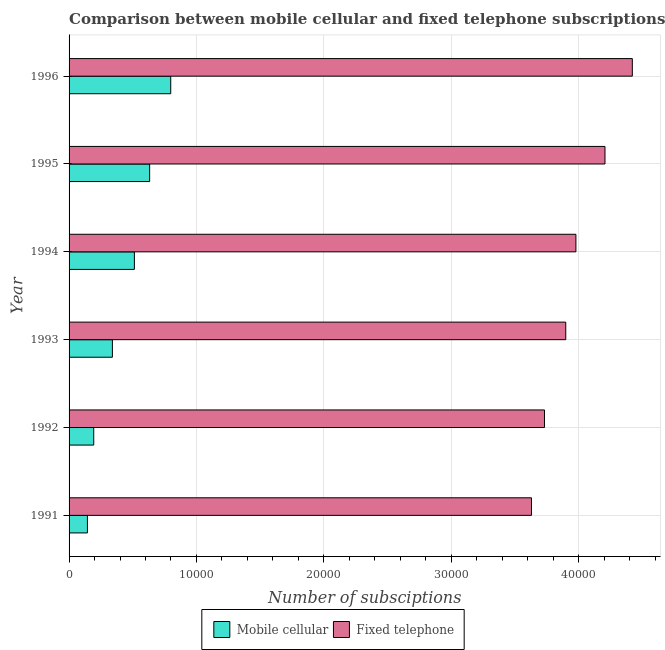How many groups of bars are there?
Your response must be concise. 6. How many bars are there on the 6th tick from the top?
Give a very brief answer. 2. What is the label of the 2nd group of bars from the top?
Keep it short and to the point. 1995. In how many cases, is the number of bars for a given year not equal to the number of legend labels?
Your response must be concise. 0. What is the number of mobile cellular subscriptions in 1993?
Make the answer very short. 3400. Across all years, what is the maximum number of mobile cellular subscriptions?
Offer a terse response. 7980. Across all years, what is the minimum number of mobile cellular subscriptions?
Offer a terse response. 1440. In which year was the number of mobile cellular subscriptions maximum?
Ensure brevity in your answer.  1996. In which year was the number of mobile cellular subscriptions minimum?
Make the answer very short. 1991. What is the total number of fixed telephone subscriptions in the graph?
Your response must be concise. 2.39e+05. What is the difference between the number of fixed telephone subscriptions in 1992 and that in 1995?
Your answer should be compact. -4749. What is the difference between the number of mobile cellular subscriptions in 1995 and the number of fixed telephone subscriptions in 1994?
Offer a very short reply. -3.35e+04. What is the average number of fixed telephone subscriptions per year?
Provide a short and direct response. 3.98e+04. In the year 1994, what is the difference between the number of mobile cellular subscriptions and number of fixed telephone subscriptions?
Give a very brief answer. -3.47e+04. What is the ratio of the number of mobile cellular subscriptions in 1995 to that in 1996?
Your answer should be compact. 0.79. Is the number of fixed telephone subscriptions in 1991 less than that in 1992?
Your response must be concise. Yes. What is the difference between the highest and the second highest number of fixed telephone subscriptions?
Provide a short and direct response. 2147. What is the difference between the highest and the lowest number of mobile cellular subscriptions?
Ensure brevity in your answer.  6540. In how many years, is the number of fixed telephone subscriptions greater than the average number of fixed telephone subscriptions taken over all years?
Make the answer very short. 3. Is the sum of the number of fixed telephone subscriptions in 1991 and 1994 greater than the maximum number of mobile cellular subscriptions across all years?
Keep it short and to the point. Yes. What does the 1st bar from the top in 1994 represents?
Your answer should be very brief. Fixed telephone. What does the 2nd bar from the bottom in 1991 represents?
Ensure brevity in your answer.  Fixed telephone. How many bars are there?
Your answer should be very brief. 12. How many years are there in the graph?
Ensure brevity in your answer.  6. Are the values on the major ticks of X-axis written in scientific E-notation?
Your response must be concise. No. Where does the legend appear in the graph?
Offer a very short reply. Bottom center. How are the legend labels stacked?
Your response must be concise. Horizontal. What is the title of the graph?
Ensure brevity in your answer.  Comparison between mobile cellular and fixed telephone subscriptions in Bermuda. Does "Canada" appear as one of the legend labels in the graph?
Keep it short and to the point. No. What is the label or title of the X-axis?
Give a very brief answer. Number of subsciptions. What is the Number of subsciptions in Mobile cellular in 1991?
Your response must be concise. 1440. What is the Number of subsciptions of Fixed telephone in 1991?
Provide a succinct answer. 3.63e+04. What is the Number of subsciptions of Mobile cellular in 1992?
Your answer should be compact. 1936. What is the Number of subsciptions of Fixed telephone in 1992?
Provide a short and direct response. 3.73e+04. What is the Number of subsciptions in Mobile cellular in 1993?
Your answer should be very brief. 3400. What is the Number of subsciptions of Fixed telephone in 1993?
Make the answer very short. 3.90e+04. What is the Number of subsciptions of Mobile cellular in 1994?
Ensure brevity in your answer.  5127. What is the Number of subsciptions in Fixed telephone in 1994?
Offer a terse response. 3.98e+04. What is the Number of subsciptions in Mobile cellular in 1995?
Make the answer very short. 6324. What is the Number of subsciptions in Fixed telephone in 1995?
Your answer should be very brief. 4.21e+04. What is the Number of subsciptions in Mobile cellular in 1996?
Provide a succinct answer. 7980. What is the Number of subsciptions in Fixed telephone in 1996?
Your response must be concise. 4.42e+04. Across all years, what is the maximum Number of subsciptions in Mobile cellular?
Ensure brevity in your answer.  7980. Across all years, what is the maximum Number of subsciptions in Fixed telephone?
Offer a very short reply. 4.42e+04. Across all years, what is the minimum Number of subsciptions in Mobile cellular?
Provide a succinct answer. 1440. Across all years, what is the minimum Number of subsciptions of Fixed telephone?
Provide a succinct answer. 3.63e+04. What is the total Number of subsciptions of Mobile cellular in the graph?
Give a very brief answer. 2.62e+04. What is the total Number of subsciptions in Fixed telephone in the graph?
Your response must be concise. 2.39e+05. What is the difference between the Number of subsciptions of Mobile cellular in 1991 and that in 1992?
Keep it short and to the point. -496. What is the difference between the Number of subsciptions of Fixed telephone in 1991 and that in 1992?
Provide a succinct answer. -1021. What is the difference between the Number of subsciptions in Mobile cellular in 1991 and that in 1993?
Keep it short and to the point. -1960. What is the difference between the Number of subsciptions in Fixed telephone in 1991 and that in 1993?
Keep it short and to the point. -2691. What is the difference between the Number of subsciptions in Mobile cellular in 1991 and that in 1994?
Your answer should be compact. -3687. What is the difference between the Number of subsciptions of Fixed telephone in 1991 and that in 1994?
Make the answer very short. -3488. What is the difference between the Number of subsciptions in Mobile cellular in 1991 and that in 1995?
Your answer should be very brief. -4884. What is the difference between the Number of subsciptions in Fixed telephone in 1991 and that in 1995?
Give a very brief answer. -5770. What is the difference between the Number of subsciptions in Mobile cellular in 1991 and that in 1996?
Make the answer very short. -6540. What is the difference between the Number of subsciptions of Fixed telephone in 1991 and that in 1996?
Your answer should be very brief. -7917. What is the difference between the Number of subsciptions of Mobile cellular in 1992 and that in 1993?
Your response must be concise. -1464. What is the difference between the Number of subsciptions in Fixed telephone in 1992 and that in 1993?
Give a very brief answer. -1670. What is the difference between the Number of subsciptions of Mobile cellular in 1992 and that in 1994?
Provide a short and direct response. -3191. What is the difference between the Number of subsciptions in Fixed telephone in 1992 and that in 1994?
Ensure brevity in your answer.  -2467. What is the difference between the Number of subsciptions of Mobile cellular in 1992 and that in 1995?
Make the answer very short. -4388. What is the difference between the Number of subsciptions in Fixed telephone in 1992 and that in 1995?
Your answer should be very brief. -4749. What is the difference between the Number of subsciptions of Mobile cellular in 1992 and that in 1996?
Your response must be concise. -6044. What is the difference between the Number of subsciptions of Fixed telephone in 1992 and that in 1996?
Your answer should be very brief. -6896. What is the difference between the Number of subsciptions of Mobile cellular in 1993 and that in 1994?
Give a very brief answer. -1727. What is the difference between the Number of subsciptions in Fixed telephone in 1993 and that in 1994?
Keep it short and to the point. -797. What is the difference between the Number of subsciptions in Mobile cellular in 1993 and that in 1995?
Your answer should be compact. -2924. What is the difference between the Number of subsciptions in Fixed telephone in 1993 and that in 1995?
Keep it short and to the point. -3079. What is the difference between the Number of subsciptions in Mobile cellular in 1993 and that in 1996?
Provide a succinct answer. -4580. What is the difference between the Number of subsciptions in Fixed telephone in 1993 and that in 1996?
Offer a terse response. -5226. What is the difference between the Number of subsciptions in Mobile cellular in 1994 and that in 1995?
Give a very brief answer. -1197. What is the difference between the Number of subsciptions in Fixed telephone in 1994 and that in 1995?
Ensure brevity in your answer.  -2282. What is the difference between the Number of subsciptions in Mobile cellular in 1994 and that in 1996?
Ensure brevity in your answer.  -2853. What is the difference between the Number of subsciptions of Fixed telephone in 1994 and that in 1996?
Keep it short and to the point. -4429. What is the difference between the Number of subsciptions of Mobile cellular in 1995 and that in 1996?
Ensure brevity in your answer.  -1656. What is the difference between the Number of subsciptions of Fixed telephone in 1995 and that in 1996?
Your response must be concise. -2147. What is the difference between the Number of subsciptions in Mobile cellular in 1991 and the Number of subsciptions in Fixed telephone in 1992?
Your answer should be very brief. -3.59e+04. What is the difference between the Number of subsciptions of Mobile cellular in 1991 and the Number of subsciptions of Fixed telephone in 1993?
Provide a short and direct response. -3.75e+04. What is the difference between the Number of subsciptions in Mobile cellular in 1991 and the Number of subsciptions in Fixed telephone in 1994?
Your answer should be compact. -3.83e+04. What is the difference between the Number of subsciptions of Mobile cellular in 1991 and the Number of subsciptions of Fixed telephone in 1995?
Provide a succinct answer. -4.06e+04. What is the difference between the Number of subsciptions in Mobile cellular in 1991 and the Number of subsciptions in Fixed telephone in 1996?
Provide a succinct answer. -4.28e+04. What is the difference between the Number of subsciptions in Mobile cellular in 1992 and the Number of subsciptions in Fixed telephone in 1993?
Offer a terse response. -3.71e+04. What is the difference between the Number of subsciptions of Mobile cellular in 1992 and the Number of subsciptions of Fixed telephone in 1994?
Keep it short and to the point. -3.78e+04. What is the difference between the Number of subsciptions in Mobile cellular in 1992 and the Number of subsciptions in Fixed telephone in 1995?
Provide a short and direct response. -4.01e+04. What is the difference between the Number of subsciptions in Mobile cellular in 1992 and the Number of subsciptions in Fixed telephone in 1996?
Provide a short and direct response. -4.23e+04. What is the difference between the Number of subsciptions of Mobile cellular in 1993 and the Number of subsciptions of Fixed telephone in 1994?
Give a very brief answer. -3.64e+04. What is the difference between the Number of subsciptions in Mobile cellular in 1993 and the Number of subsciptions in Fixed telephone in 1995?
Your answer should be compact. -3.87e+04. What is the difference between the Number of subsciptions of Mobile cellular in 1993 and the Number of subsciptions of Fixed telephone in 1996?
Offer a very short reply. -4.08e+04. What is the difference between the Number of subsciptions in Mobile cellular in 1994 and the Number of subsciptions in Fixed telephone in 1995?
Your answer should be very brief. -3.69e+04. What is the difference between the Number of subsciptions of Mobile cellular in 1994 and the Number of subsciptions of Fixed telephone in 1996?
Keep it short and to the point. -3.91e+04. What is the difference between the Number of subsciptions of Mobile cellular in 1995 and the Number of subsciptions of Fixed telephone in 1996?
Keep it short and to the point. -3.79e+04. What is the average Number of subsciptions in Mobile cellular per year?
Keep it short and to the point. 4367.83. What is the average Number of subsciptions of Fixed telephone per year?
Keep it short and to the point. 3.98e+04. In the year 1991, what is the difference between the Number of subsciptions in Mobile cellular and Number of subsciptions in Fixed telephone?
Your response must be concise. -3.49e+04. In the year 1992, what is the difference between the Number of subsciptions of Mobile cellular and Number of subsciptions of Fixed telephone?
Ensure brevity in your answer.  -3.54e+04. In the year 1993, what is the difference between the Number of subsciptions in Mobile cellular and Number of subsciptions in Fixed telephone?
Keep it short and to the point. -3.56e+04. In the year 1994, what is the difference between the Number of subsciptions in Mobile cellular and Number of subsciptions in Fixed telephone?
Your response must be concise. -3.47e+04. In the year 1995, what is the difference between the Number of subsciptions in Mobile cellular and Number of subsciptions in Fixed telephone?
Give a very brief answer. -3.57e+04. In the year 1996, what is the difference between the Number of subsciptions of Mobile cellular and Number of subsciptions of Fixed telephone?
Your answer should be very brief. -3.62e+04. What is the ratio of the Number of subsciptions in Mobile cellular in 1991 to that in 1992?
Offer a very short reply. 0.74. What is the ratio of the Number of subsciptions in Fixed telephone in 1991 to that in 1992?
Keep it short and to the point. 0.97. What is the ratio of the Number of subsciptions in Mobile cellular in 1991 to that in 1993?
Offer a terse response. 0.42. What is the ratio of the Number of subsciptions of Fixed telephone in 1991 to that in 1993?
Offer a terse response. 0.93. What is the ratio of the Number of subsciptions of Mobile cellular in 1991 to that in 1994?
Provide a succinct answer. 0.28. What is the ratio of the Number of subsciptions of Fixed telephone in 1991 to that in 1994?
Keep it short and to the point. 0.91. What is the ratio of the Number of subsciptions in Mobile cellular in 1991 to that in 1995?
Provide a succinct answer. 0.23. What is the ratio of the Number of subsciptions in Fixed telephone in 1991 to that in 1995?
Offer a very short reply. 0.86. What is the ratio of the Number of subsciptions in Mobile cellular in 1991 to that in 1996?
Your answer should be very brief. 0.18. What is the ratio of the Number of subsciptions of Fixed telephone in 1991 to that in 1996?
Your answer should be compact. 0.82. What is the ratio of the Number of subsciptions in Mobile cellular in 1992 to that in 1993?
Your response must be concise. 0.57. What is the ratio of the Number of subsciptions in Fixed telephone in 1992 to that in 1993?
Offer a terse response. 0.96. What is the ratio of the Number of subsciptions of Mobile cellular in 1992 to that in 1994?
Offer a terse response. 0.38. What is the ratio of the Number of subsciptions in Fixed telephone in 1992 to that in 1994?
Keep it short and to the point. 0.94. What is the ratio of the Number of subsciptions in Mobile cellular in 1992 to that in 1995?
Offer a very short reply. 0.31. What is the ratio of the Number of subsciptions of Fixed telephone in 1992 to that in 1995?
Keep it short and to the point. 0.89. What is the ratio of the Number of subsciptions in Mobile cellular in 1992 to that in 1996?
Provide a succinct answer. 0.24. What is the ratio of the Number of subsciptions of Fixed telephone in 1992 to that in 1996?
Make the answer very short. 0.84. What is the ratio of the Number of subsciptions of Mobile cellular in 1993 to that in 1994?
Your answer should be compact. 0.66. What is the ratio of the Number of subsciptions of Fixed telephone in 1993 to that in 1994?
Offer a very short reply. 0.98. What is the ratio of the Number of subsciptions in Mobile cellular in 1993 to that in 1995?
Provide a short and direct response. 0.54. What is the ratio of the Number of subsciptions in Fixed telephone in 1993 to that in 1995?
Give a very brief answer. 0.93. What is the ratio of the Number of subsciptions in Mobile cellular in 1993 to that in 1996?
Your answer should be very brief. 0.43. What is the ratio of the Number of subsciptions in Fixed telephone in 1993 to that in 1996?
Give a very brief answer. 0.88. What is the ratio of the Number of subsciptions of Mobile cellular in 1994 to that in 1995?
Your response must be concise. 0.81. What is the ratio of the Number of subsciptions in Fixed telephone in 1994 to that in 1995?
Your answer should be very brief. 0.95. What is the ratio of the Number of subsciptions of Mobile cellular in 1994 to that in 1996?
Your response must be concise. 0.64. What is the ratio of the Number of subsciptions of Fixed telephone in 1994 to that in 1996?
Make the answer very short. 0.9. What is the ratio of the Number of subsciptions of Mobile cellular in 1995 to that in 1996?
Ensure brevity in your answer.  0.79. What is the ratio of the Number of subsciptions in Fixed telephone in 1995 to that in 1996?
Your answer should be compact. 0.95. What is the difference between the highest and the second highest Number of subsciptions of Mobile cellular?
Your answer should be very brief. 1656. What is the difference between the highest and the second highest Number of subsciptions in Fixed telephone?
Your answer should be very brief. 2147. What is the difference between the highest and the lowest Number of subsciptions of Mobile cellular?
Make the answer very short. 6540. What is the difference between the highest and the lowest Number of subsciptions in Fixed telephone?
Your response must be concise. 7917. 